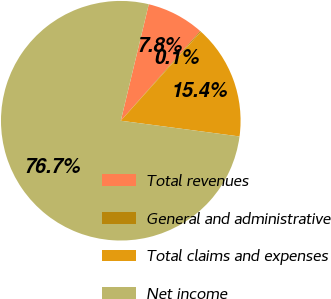Convert chart. <chart><loc_0><loc_0><loc_500><loc_500><pie_chart><fcel>Total revenues<fcel>General and administrative<fcel>Total claims and expenses<fcel>Net income<nl><fcel>7.78%<fcel>0.13%<fcel>15.43%<fcel>76.66%<nl></chart> 